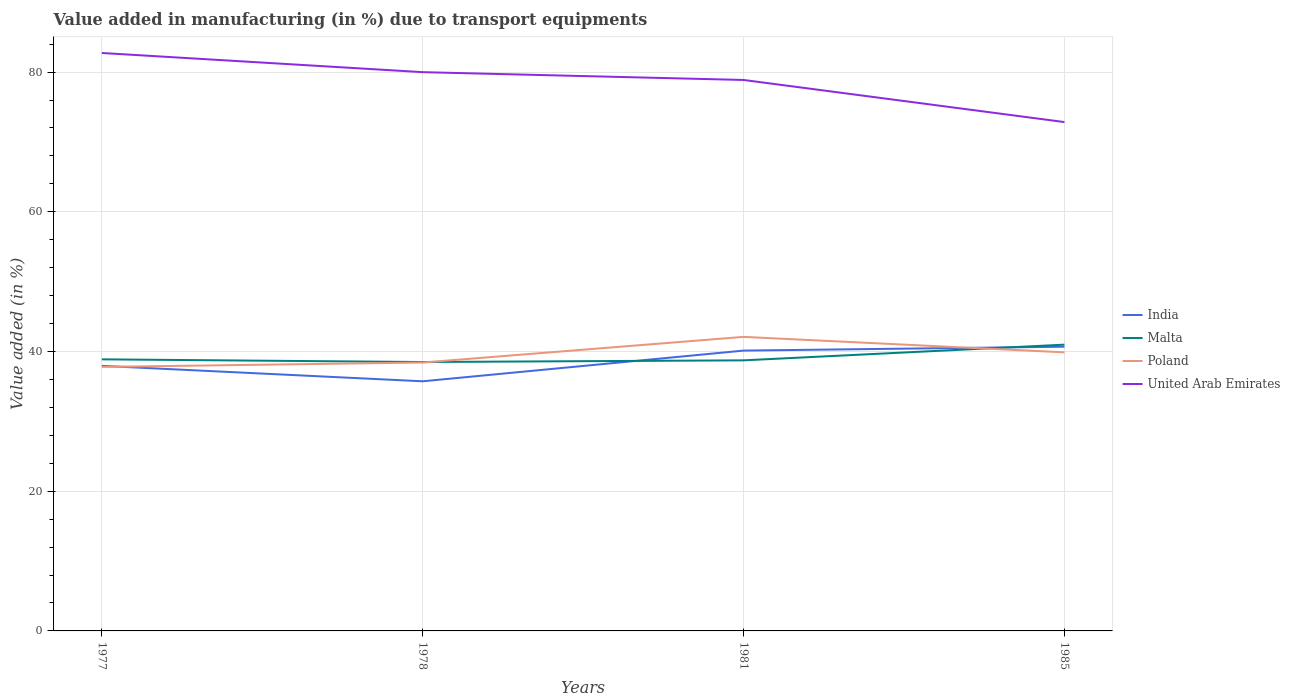Is the number of lines equal to the number of legend labels?
Your response must be concise. Yes. Across all years, what is the maximum percentage of value added in manufacturing due to transport equipments in Malta?
Your answer should be compact. 38.49. What is the total percentage of value added in manufacturing due to transport equipments in United Arab Emirates in the graph?
Your answer should be compact. 2.74. What is the difference between the highest and the second highest percentage of value added in manufacturing due to transport equipments in India?
Ensure brevity in your answer.  4.95. How many lines are there?
Your answer should be compact. 4. Are the values on the major ticks of Y-axis written in scientific E-notation?
Give a very brief answer. No. Does the graph contain grids?
Provide a succinct answer. Yes. Where does the legend appear in the graph?
Offer a very short reply. Center right. What is the title of the graph?
Ensure brevity in your answer.  Value added in manufacturing (in %) due to transport equipments. What is the label or title of the X-axis?
Keep it short and to the point. Years. What is the label or title of the Y-axis?
Your answer should be very brief. Value added (in %). What is the Value added (in %) of India in 1977?
Make the answer very short. 37.94. What is the Value added (in %) of Malta in 1977?
Your answer should be compact. 38.88. What is the Value added (in %) in Poland in 1977?
Provide a short and direct response. 37.79. What is the Value added (in %) of United Arab Emirates in 1977?
Give a very brief answer. 82.73. What is the Value added (in %) of India in 1978?
Your answer should be compact. 35.73. What is the Value added (in %) in Malta in 1978?
Your answer should be very brief. 38.49. What is the Value added (in %) of Poland in 1978?
Provide a succinct answer. 38.42. What is the Value added (in %) of United Arab Emirates in 1978?
Offer a terse response. 79.99. What is the Value added (in %) of India in 1981?
Offer a terse response. 40.13. What is the Value added (in %) of Malta in 1981?
Your answer should be very brief. 38.73. What is the Value added (in %) of Poland in 1981?
Provide a succinct answer. 42.09. What is the Value added (in %) in United Arab Emirates in 1981?
Offer a terse response. 78.87. What is the Value added (in %) in India in 1985?
Provide a succinct answer. 40.69. What is the Value added (in %) of Malta in 1985?
Give a very brief answer. 40.98. What is the Value added (in %) of Poland in 1985?
Provide a short and direct response. 39.88. What is the Value added (in %) in United Arab Emirates in 1985?
Provide a succinct answer. 72.84. Across all years, what is the maximum Value added (in %) of India?
Provide a succinct answer. 40.69. Across all years, what is the maximum Value added (in %) in Malta?
Ensure brevity in your answer.  40.98. Across all years, what is the maximum Value added (in %) in Poland?
Your answer should be compact. 42.09. Across all years, what is the maximum Value added (in %) in United Arab Emirates?
Provide a short and direct response. 82.73. Across all years, what is the minimum Value added (in %) in India?
Your answer should be compact. 35.73. Across all years, what is the minimum Value added (in %) in Malta?
Offer a very short reply. 38.49. Across all years, what is the minimum Value added (in %) of Poland?
Keep it short and to the point. 37.79. Across all years, what is the minimum Value added (in %) in United Arab Emirates?
Keep it short and to the point. 72.84. What is the total Value added (in %) of India in the graph?
Give a very brief answer. 154.49. What is the total Value added (in %) in Malta in the graph?
Offer a very short reply. 157.08. What is the total Value added (in %) of Poland in the graph?
Your response must be concise. 158.18. What is the total Value added (in %) of United Arab Emirates in the graph?
Your answer should be very brief. 314.43. What is the difference between the Value added (in %) of India in 1977 and that in 1978?
Your answer should be compact. 2.21. What is the difference between the Value added (in %) in Malta in 1977 and that in 1978?
Your answer should be very brief. 0.38. What is the difference between the Value added (in %) in Poland in 1977 and that in 1978?
Ensure brevity in your answer.  -0.63. What is the difference between the Value added (in %) in United Arab Emirates in 1977 and that in 1978?
Give a very brief answer. 2.74. What is the difference between the Value added (in %) in India in 1977 and that in 1981?
Offer a very short reply. -2.18. What is the difference between the Value added (in %) of Malta in 1977 and that in 1981?
Offer a terse response. 0.14. What is the difference between the Value added (in %) in Poland in 1977 and that in 1981?
Provide a short and direct response. -4.3. What is the difference between the Value added (in %) in United Arab Emirates in 1977 and that in 1981?
Make the answer very short. 3.86. What is the difference between the Value added (in %) in India in 1977 and that in 1985?
Ensure brevity in your answer.  -2.74. What is the difference between the Value added (in %) of Malta in 1977 and that in 1985?
Keep it short and to the point. -2.1. What is the difference between the Value added (in %) in Poland in 1977 and that in 1985?
Make the answer very short. -2.08. What is the difference between the Value added (in %) of United Arab Emirates in 1977 and that in 1985?
Provide a succinct answer. 9.89. What is the difference between the Value added (in %) in India in 1978 and that in 1981?
Give a very brief answer. -4.39. What is the difference between the Value added (in %) in Malta in 1978 and that in 1981?
Offer a very short reply. -0.24. What is the difference between the Value added (in %) in Poland in 1978 and that in 1981?
Offer a very short reply. -3.67. What is the difference between the Value added (in %) of United Arab Emirates in 1978 and that in 1981?
Keep it short and to the point. 1.12. What is the difference between the Value added (in %) of India in 1978 and that in 1985?
Offer a terse response. -4.95. What is the difference between the Value added (in %) of Malta in 1978 and that in 1985?
Provide a short and direct response. -2.49. What is the difference between the Value added (in %) of Poland in 1978 and that in 1985?
Your response must be concise. -1.46. What is the difference between the Value added (in %) in United Arab Emirates in 1978 and that in 1985?
Make the answer very short. 7.14. What is the difference between the Value added (in %) in India in 1981 and that in 1985?
Keep it short and to the point. -0.56. What is the difference between the Value added (in %) in Malta in 1981 and that in 1985?
Provide a succinct answer. -2.24. What is the difference between the Value added (in %) in Poland in 1981 and that in 1985?
Your response must be concise. 2.21. What is the difference between the Value added (in %) in United Arab Emirates in 1981 and that in 1985?
Your answer should be very brief. 6.03. What is the difference between the Value added (in %) in India in 1977 and the Value added (in %) in Malta in 1978?
Your answer should be compact. -0.55. What is the difference between the Value added (in %) in India in 1977 and the Value added (in %) in Poland in 1978?
Make the answer very short. -0.48. What is the difference between the Value added (in %) in India in 1977 and the Value added (in %) in United Arab Emirates in 1978?
Offer a very short reply. -42.04. What is the difference between the Value added (in %) in Malta in 1977 and the Value added (in %) in Poland in 1978?
Provide a short and direct response. 0.46. What is the difference between the Value added (in %) of Malta in 1977 and the Value added (in %) of United Arab Emirates in 1978?
Provide a succinct answer. -41.11. What is the difference between the Value added (in %) in Poland in 1977 and the Value added (in %) in United Arab Emirates in 1978?
Keep it short and to the point. -42.19. What is the difference between the Value added (in %) in India in 1977 and the Value added (in %) in Malta in 1981?
Provide a short and direct response. -0.79. What is the difference between the Value added (in %) of India in 1977 and the Value added (in %) of Poland in 1981?
Make the answer very short. -4.15. What is the difference between the Value added (in %) in India in 1977 and the Value added (in %) in United Arab Emirates in 1981?
Your answer should be very brief. -40.92. What is the difference between the Value added (in %) in Malta in 1977 and the Value added (in %) in Poland in 1981?
Offer a terse response. -3.22. What is the difference between the Value added (in %) in Malta in 1977 and the Value added (in %) in United Arab Emirates in 1981?
Offer a terse response. -39.99. What is the difference between the Value added (in %) in Poland in 1977 and the Value added (in %) in United Arab Emirates in 1981?
Make the answer very short. -41.07. What is the difference between the Value added (in %) in India in 1977 and the Value added (in %) in Malta in 1985?
Provide a succinct answer. -3.03. What is the difference between the Value added (in %) in India in 1977 and the Value added (in %) in Poland in 1985?
Keep it short and to the point. -1.94. What is the difference between the Value added (in %) of India in 1977 and the Value added (in %) of United Arab Emirates in 1985?
Provide a short and direct response. -34.9. What is the difference between the Value added (in %) of Malta in 1977 and the Value added (in %) of Poland in 1985?
Your answer should be very brief. -1. What is the difference between the Value added (in %) of Malta in 1977 and the Value added (in %) of United Arab Emirates in 1985?
Make the answer very short. -33.97. What is the difference between the Value added (in %) of Poland in 1977 and the Value added (in %) of United Arab Emirates in 1985?
Make the answer very short. -35.05. What is the difference between the Value added (in %) of India in 1978 and the Value added (in %) of Malta in 1981?
Provide a short and direct response. -3. What is the difference between the Value added (in %) of India in 1978 and the Value added (in %) of Poland in 1981?
Offer a terse response. -6.36. What is the difference between the Value added (in %) in India in 1978 and the Value added (in %) in United Arab Emirates in 1981?
Ensure brevity in your answer.  -43.13. What is the difference between the Value added (in %) in Malta in 1978 and the Value added (in %) in United Arab Emirates in 1981?
Give a very brief answer. -40.38. What is the difference between the Value added (in %) in Poland in 1978 and the Value added (in %) in United Arab Emirates in 1981?
Ensure brevity in your answer.  -40.45. What is the difference between the Value added (in %) in India in 1978 and the Value added (in %) in Malta in 1985?
Your answer should be compact. -5.24. What is the difference between the Value added (in %) in India in 1978 and the Value added (in %) in Poland in 1985?
Provide a succinct answer. -4.14. What is the difference between the Value added (in %) in India in 1978 and the Value added (in %) in United Arab Emirates in 1985?
Keep it short and to the point. -37.11. What is the difference between the Value added (in %) of Malta in 1978 and the Value added (in %) of Poland in 1985?
Provide a succinct answer. -1.39. What is the difference between the Value added (in %) of Malta in 1978 and the Value added (in %) of United Arab Emirates in 1985?
Offer a terse response. -34.35. What is the difference between the Value added (in %) of Poland in 1978 and the Value added (in %) of United Arab Emirates in 1985?
Keep it short and to the point. -34.42. What is the difference between the Value added (in %) of India in 1981 and the Value added (in %) of Malta in 1985?
Your response must be concise. -0.85. What is the difference between the Value added (in %) in India in 1981 and the Value added (in %) in Poland in 1985?
Offer a very short reply. 0.25. What is the difference between the Value added (in %) in India in 1981 and the Value added (in %) in United Arab Emirates in 1985?
Provide a short and direct response. -32.71. What is the difference between the Value added (in %) of Malta in 1981 and the Value added (in %) of Poland in 1985?
Your answer should be very brief. -1.15. What is the difference between the Value added (in %) of Malta in 1981 and the Value added (in %) of United Arab Emirates in 1985?
Provide a short and direct response. -34.11. What is the difference between the Value added (in %) in Poland in 1981 and the Value added (in %) in United Arab Emirates in 1985?
Your answer should be compact. -30.75. What is the average Value added (in %) of India per year?
Your response must be concise. 38.62. What is the average Value added (in %) of Malta per year?
Make the answer very short. 39.27. What is the average Value added (in %) in Poland per year?
Provide a succinct answer. 39.55. What is the average Value added (in %) in United Arab Emirates per year?
Your answer should be very brief. 78.61. In the year 1977, what is the difference between the Value added (in %) in India and Value added (in %) in Malta?
Provide a succinct answer. -0.93. In the year 1977, what is the difference between the Value added (in %) of India and Value added (in %) of Poland?
Offer a very short reply. 0.15. In the year 1977, what is the difference between the Value added (in %) in India and Value added (in %) in United Arab Emirates?
Keep it short and to the point. -44.79. In the year 1977, what is the difference between the Value added (in %) of Malta and Value added (in %) of Poland?
Offer a terse response. 1.08. In the year 1977, what is the difference between the Value added (in %) in Malta and Value added (in %) in United Arab Emirates?
Make the answer very short. -43.85. In the year 1977, what is the difference between the Value added (in %) in Poland and Value added (in %) in United Arab Emirates?
Your answer should be very brief. -44.94. In the year 1978, what is the difference between the Value added (in %) in India and Value added (in %) in Malta?
Offer a terse response. -2.76. In the year 1978, what is the difference between the Value added (in %) of India and Value added (in %) of Poland?
Your answer should be very brief. -2.69. In the year 1978, what is the difference between the Value added (in %) of India and Value added (in %) of United Arab Emirates?
Offer a terse response. -44.25. In the year 1978, what is the difference between the Value added (in %) of Malta and Value added (in %) of Poland?
Your answer should be very brief. 0.07. In the year 1978, what is the difference between the Value added (in %) in Malta and Value added (in %) in United Arab Emirates?
Keep it short and to the point. -41.49. In the year 1978, what is the difference between the Value added (in %) in Poland and Value added (in %) in United Arab Emirates?
Provide a succinct answer. -41.57. In the year 1981, what is the difference between the Value added (in %) of India and Value added (in %) of Malta?
Provide a short and direct response. 1.4. In the year 1981, what is the difference between the Value added (in %) of India and Value added (in %) of Poland?
Make the answer very short. -1.96. In the year 1981, what is the difference between the Value added (in %) of India and Value added (in %) of United Arab Emirates?
Ensure brevity in your answer.  -38.74. In the year 1981, what is the difference between the Value added (in %) of Malta and Value added (in %) of Poland?
Provide a short and direct response. -3.36. In the year 1981, what is the difference between the Value added (in %) in Malta and Value added (in %) in United Arab Emirates?
Make the answer very short. -40.14. In the year 1981, what is the difference between the Value added (in %) of Poland and Value added (in %) of United Arab Emirates?
Provide a short and direct response. -36.78. In the year 1985, what is the difference between the Value added (in %) in India and Value added (in %) in Malta?
Make the answer very short. -0.29. In the year 1985, what is the difference between the Value added (in %) in India and Value added (in %) in Poland?
Keep it short and to the point. 0.81. In the year 1985, what is the difference between the Value added (in %) in India and Value added (in %) in United Arab Emirates?
Your answer should be compact. -32.16. In the year 1985, what is the difference between the Value added (in %) of Malta and Value added (in %) of Poland?
Your answer should be compact. 1.1. In the year 1985, what is the difference between the Value added (in %) in Malta and Value added (in %) in United Arab Emirates?
Make the answer very short. -31.86. In the year 1985, what is the difference between the Value added (in %) of Poland and Value added (in %) of United Arab Emirates?
Your response must be concise. -32.96. What is the ratio of the Value added (in %) in India in 1977 to that in 1978?
Ensure brevity in your answer.  1.06. What is the ratio of the Value added (in %) of Malta in 1977 to that in 1978?
Offer a terse response. 1.01. What is the ratio of the Value added (in %) in Poland in 1977 to that in 1978?
Offer a terse response. 0.98. What is the ratio of the Value added (in %) of United Arab Emirates in 1977 to that in 1978?
Give a very brief answer. 1.03. What is the ratio of the Value added (in %) of India in 1977 to that in 1981?
Ensure brevity in your answer.  0.95. What is the ratio of the Value added (in %) in Poland in 1977 to that in 1981?
Make the answer very short. 0.9. What is the ratio of the Value added (in %) in United Arab Emirates in 1977 to that in 1981?
Give a very brief answer. 1.05. What is the ratio of the Value added (in %) in India in 1977 to that in 1985?
Offer a very short reply. 0.93. What is the ratio of the Value added (in %) of Malta in 1977 to that in 1985?
Your answer should be very brief. 0.95. What is the ratio of the Value added (in %) of Poland in 1977 to that in 1985?
Your response must be concise. 0.95. What is the ratio of the Value added (in %) in United Arab Emirates in 1977 to that in 1985?
Your answer should be compact. 1.14. What is the ratio of the Value added (in %) in India in 1978 to that in 1981?
Your answer should be very brief. 0.89. What is the ratio of the Value added (in %) in Malta in 1978 to that in 1981?
Your response must be concise. 0.99. What is the ratio of the Value added (in %) of Poland in 1978 to that in 1981?
Provide a succinct answer. 0.91. What is the ratio of the Value added (in %) in United Arab Emirates in 1978 to that in 1981?
Ensure brevity in your answer.  1.01. What is the ratio of the Value added (in %) of India in 1978 to that in 1985?
Offer a terse response. 0.88. What is the ratio of the Value added (in %) of Malta in 1978 to that in 1985?
Keep it short and to the point. 0.94. What is the ratio of the Value added (in %) in Poland in 1978 to that in 1985?
Give a very brief answer. 0.96. What is the ratio of the Value added (in %) of United Arab Emirates in 1978 to that in 1985?
Offer a terse response. 1.1. What is the ratio of the Value added (in %) of India in 1981 to that in 1985?
Your answer should be very brief. 0.99. What is the ratio of the Value added (in %) of Malta in 1981 to that in 1985?
Make the answer very short. 0.95. What is the ratio of the Value added (in %) in Poland in 1981 to that in 1985?
Ensure brevity in your answer.  1.06. What is the ratio of the Value added (in %) of United Arab Emirates in 1981 to that in 1985?
Your answer should be compact. 1.08. What is the difference between the highest and the second highest Value added (in %) of India?
Offer a terse response. 0.56. What is the difference between the highest and the second highest Value added (in %) of Malta?
Your answer should be very brief. 2.1. What is the difference between the highest and the second highest Value added (in %) in Poland?
Ensure brevity in your answer.  2.21. What is the difference between the highest and the second highest Value added (in %) of United Arab Emirates?
Make the answer very short. 2.74. What is the difference between the highest and the lowest Value added (in %) in India?
Your answer should be compact. 4.95. What is the difference between the highest and the lowest Value added (in %) of Malta?
Offer a terse response. 2.49. What is the difference between the highest and the lowest Value added (in %) of Poland?
Your answer should be very brief. 4.3. What is the difference between the highest and the lowest Value added (in %) in United Arab Emirates?
Provide a succinct answer. 9.89. 